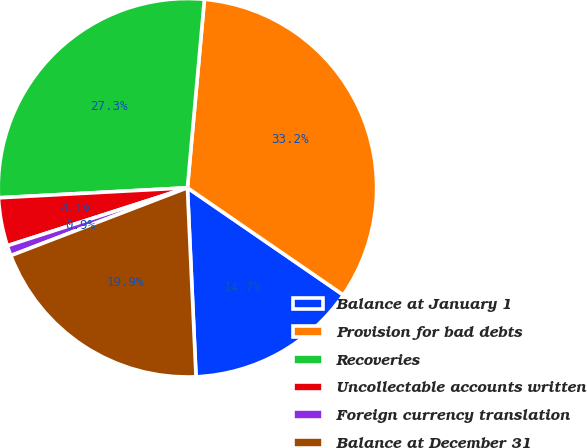Convert chart. <chart><loc_0><loc_0><loc_500><loc_500><pie_chart><fcel>Balance at January 1<fcel>Provision for bad debts<fcel>Recoveries<fcel>Uncollectable accounts written<fcel>Foreign currency translation<fcel>Balance at December 31<nl><fcel>14.69%<fcel>33.16%<fcel>27.28%<fcel>4.11%<fcel>0.88%<fcel>19.89%<nl></chart> 